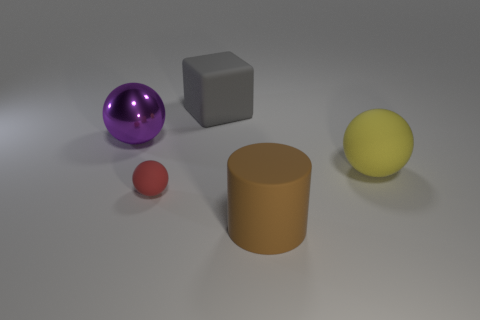Add 2 blocks. How many objects exist? 7 Subtract all big yellow rubber balls. How many balls are left? 2 Subtract all red balls. How many balls are left? 2 Subtract all balls. How many objects are left? 2 Subtract all purple blocks. Subtract all purple spheres. How many blocks are left? 1 Subtract all tiny red spheres. Subtract all big matte objects. How many objects are left? 1 Add 1 big cubes. How many big cubes are left? 2 Add 2 small objects. How many small objects exist? 3 Subtract 1 yellow balls. How many objects are left? 4 Subtract 1 blocks. How many blocks are left? 0 